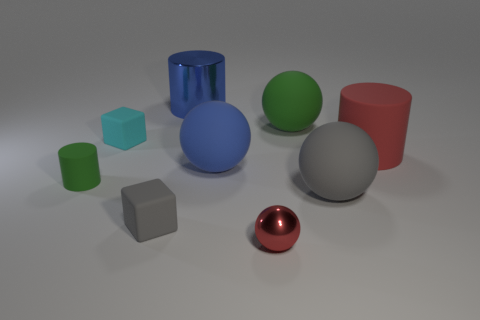Subtract all big cylinders. How many cylinders are left? 1 Add 1 tiny green metallic spheres. How many objects exist? 10 Subtract all balls. How many objects are left? 5 Subtract all green spheres. How many spheres are left? 3 Subtract 1 cylinders. How many cylinders are left? 2 Subtract all yellow spheres. How many brown cylinders are left? 0 Subtract all big blue metallic cylinders. Subtract all red metallic blocks. How many objects are left? 8 Add 6 green rubber balls. How many green rubber balls are left? 7 Add 4 tiny purple balls. How many tiny purple balls exist? 4 Subtract 0 yellow spheres. How many objects are left? 9 